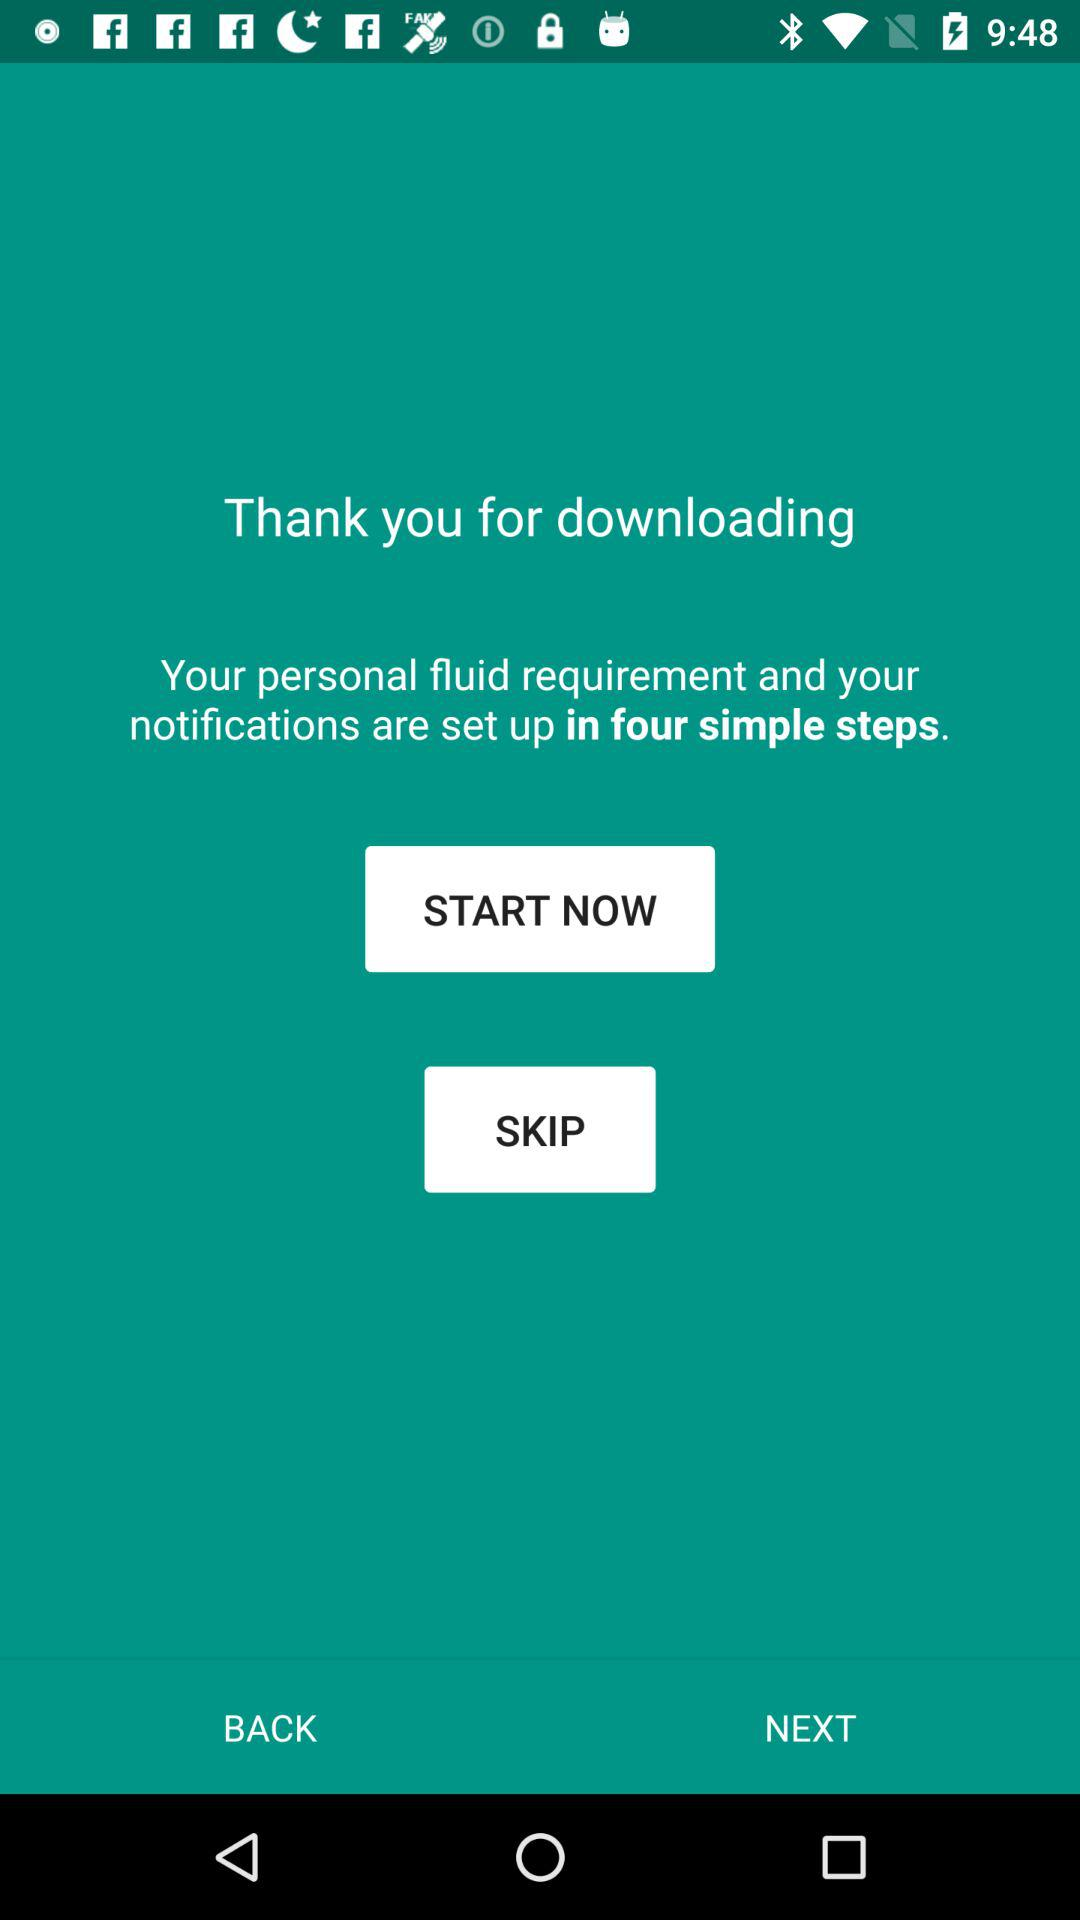How many steps does it take to set up your notifications?
Answer the question using a single word or phrase. 4 